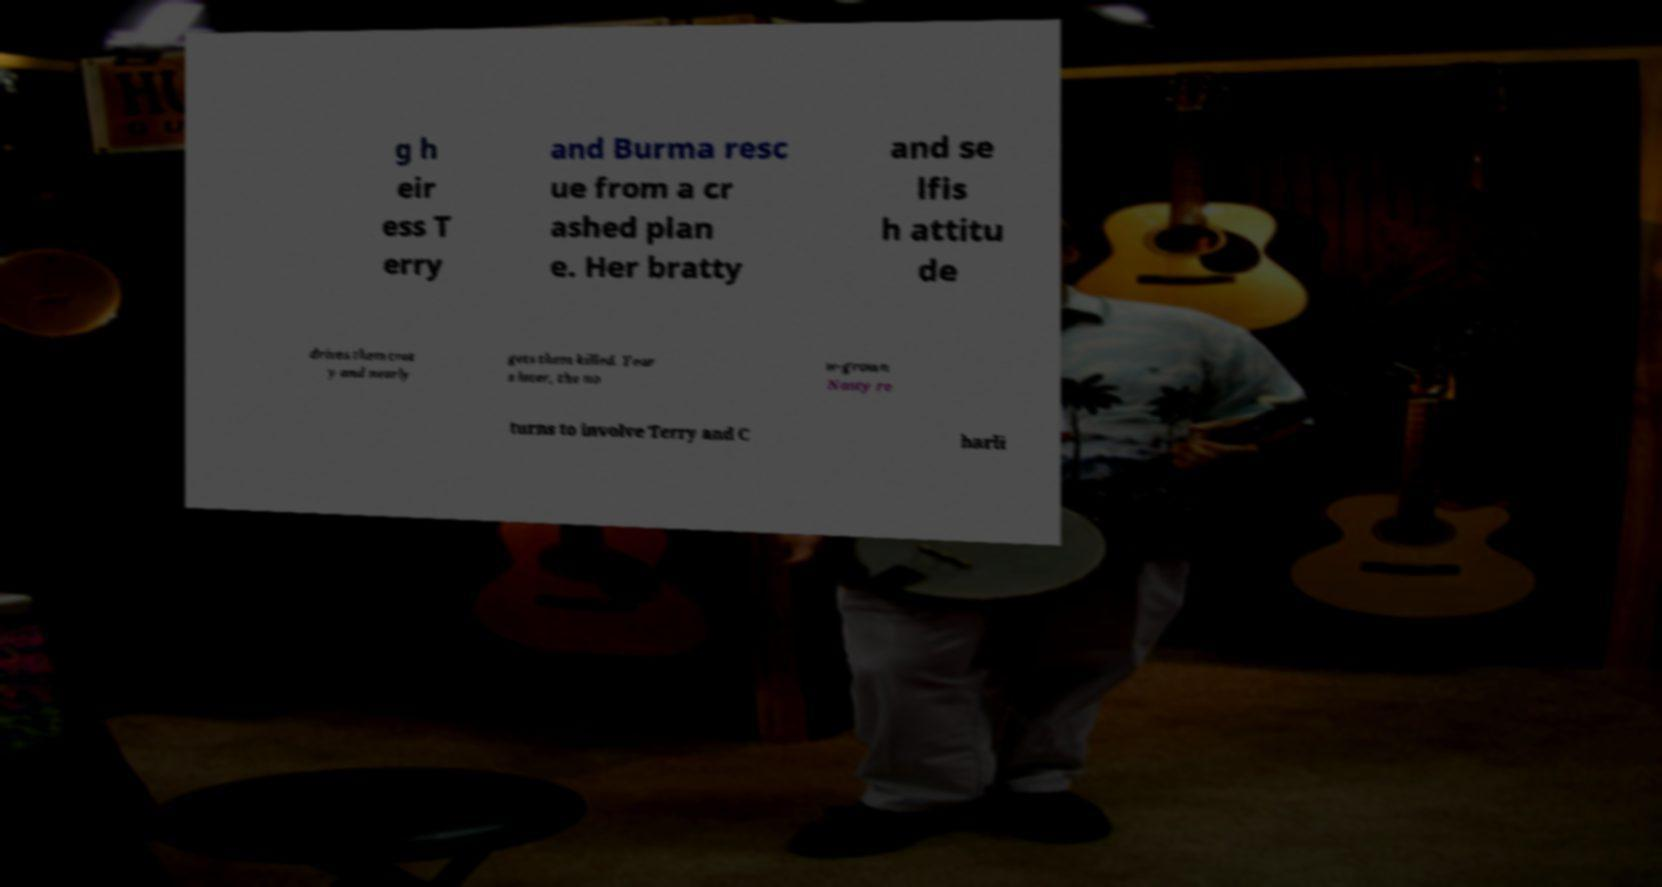Could you extract and type out the text from this image? g h eir ess T erry and Burma resc ue from a cr ashed plan e. Her bratty and se lfis h attitu de drives them craz y and nearly gets them killed. Year s later, the no w-grown Nasty re turns to involve Terry and C harli 